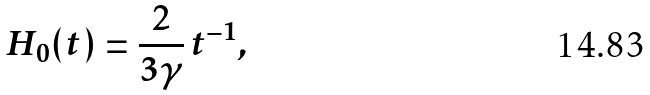Convert formula to latex. <formula><loc_0><loc_0><loc_500><loc_500>H _ { 0 } ( t ) = \frac { 2 } { 3 \gamma } \, t ^ { - 1 } ,</formula> 